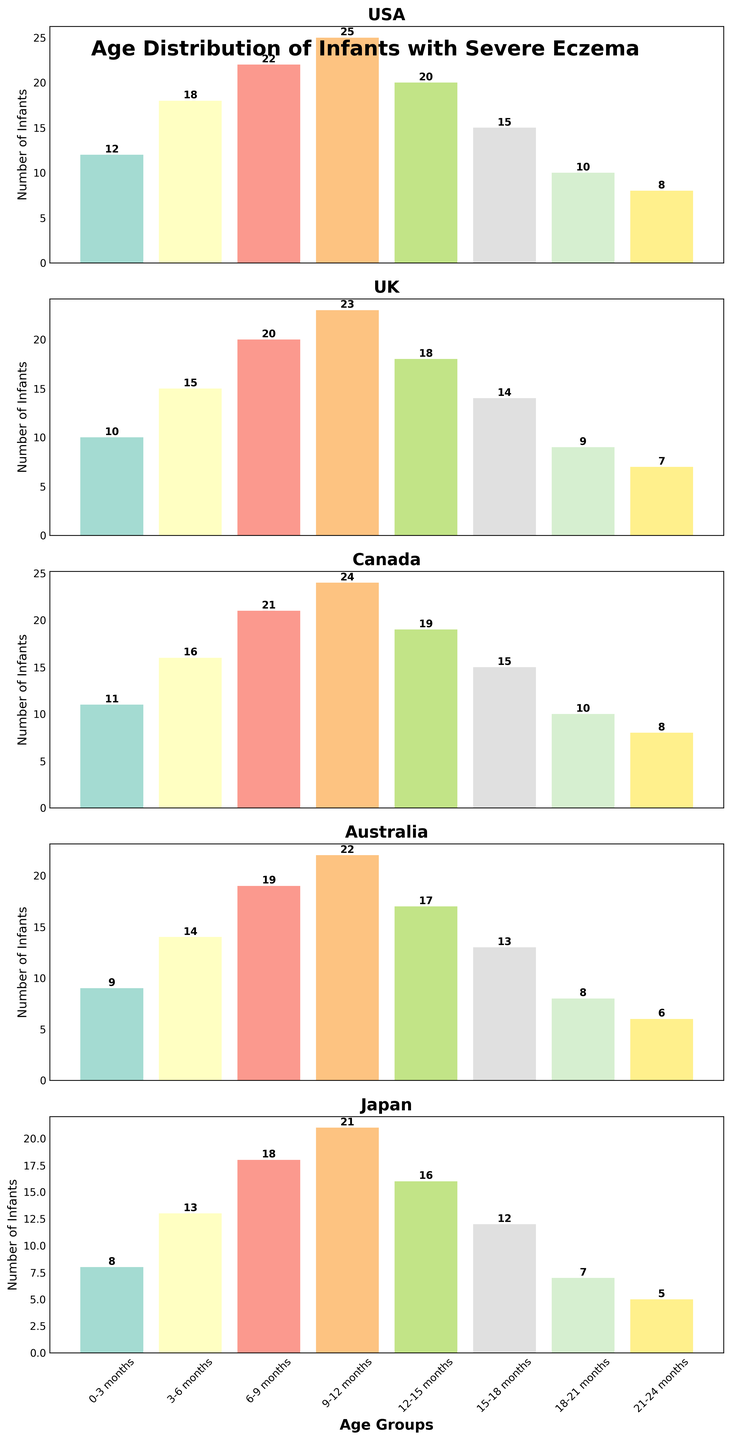Which age group has the highest number of infants diagnosed with severe eczema in the USA? Observe the bar heights in the USA subplot. The bar representing the 9-12 months age group is the tallest.
Answer: 9-12 months At which age group do the number of infants diagnosed with eczema start decreasing in Canada? In the Canada subplot, after the 9-12 months group, the number of infants diagnosed decreases consistently.
Answer: 12-15 months Which country has the lowest number of infants diagnosed with severe eczema in the 0-3 months age group? Compare the height of the bars for the 0-3 months age group across all the subplots. The bar for Japan is the shortest.
Answer: Japan In the UK, how many more infants are diagnosed with severe eczema in the 9-12 months age group compared to the 3-6 months age group? Subtract the number of infants in the 3-6 months age group (15) from the 9-12 months age group (23).
Answer: 8 What is the average number of infants diagnosed with severe eczema in the 15-18 months age group across all countries? Add the number of infants for each country in the 15-18 months age group (15+14+15+13+12) and divide by 5.
Answer: 13.8 Which country shows the steepest decline in the number of infants diagnosed with severe eczema from the 12-15 months to the 21-24 months age group? Look at the decline in numbers from the 12-15 months to the 21-24 months age group in each subplot. The steepest decline is in Japan (16 to 5).
Answer: Japan In Australia, what is the sum of infants diagnosed with severe eczema in the 6-9 months and 9-12 months age groups? Add the number of infants in the 6-9 months (19) and 9-12 months (22) age groups.
Answer: 41 Which country has the consistent decrease in the number of infants diagnosed with severe eczema post the 9-12 months age group? Observe all subplots for a consistent decrease after the 9-12 months age group. Canada shows a consistent decrease.
Answer: Canada 